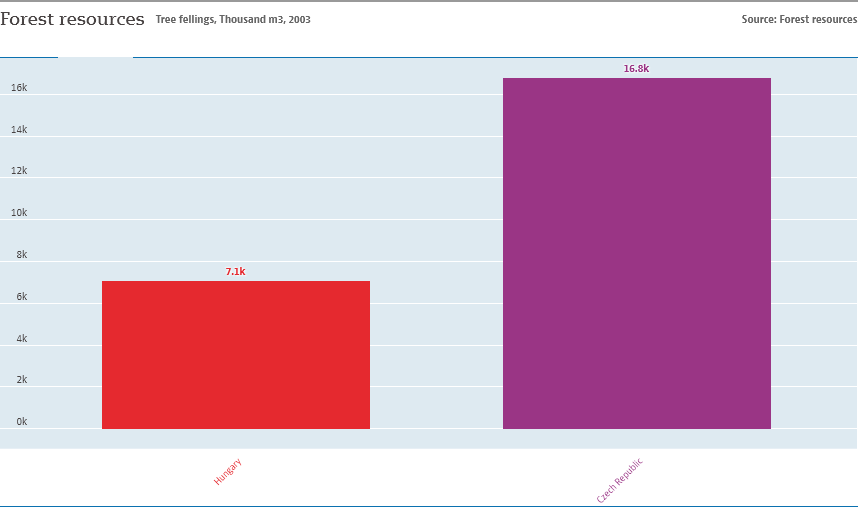Mention a couple of crucial points in this snapshot. The smallest bar is valued at 7.1. The largest bar value is not two times the value of the smallest bar. 